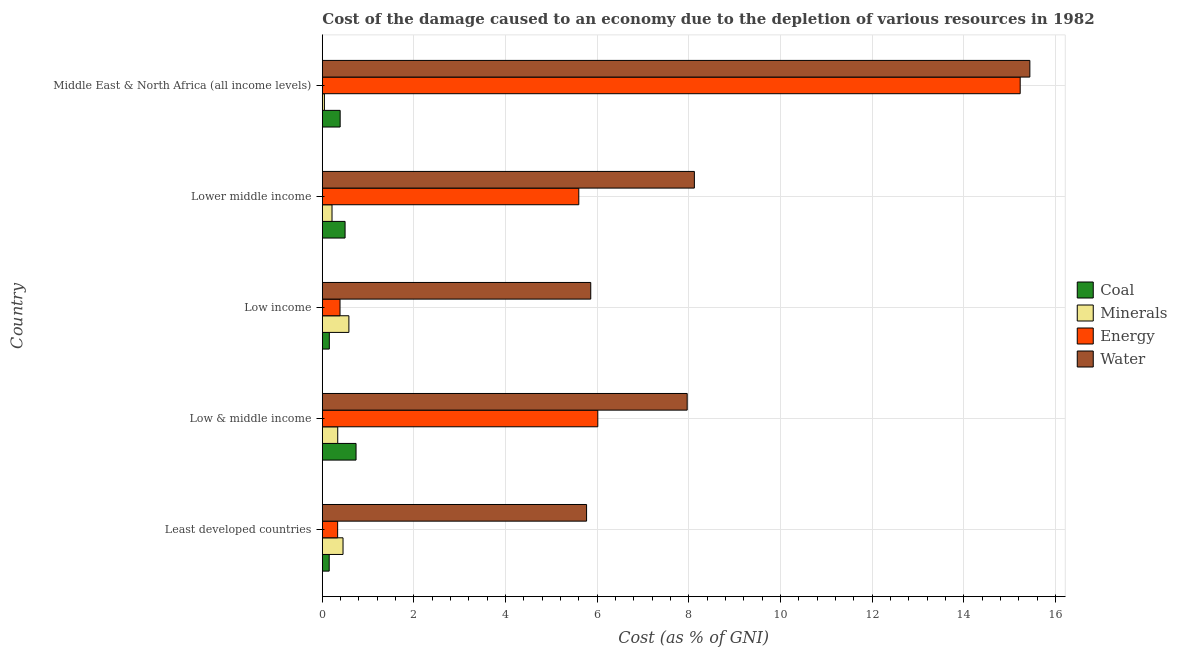How many bars are there on the 4th tick from the top?
Ensure brevity in your answer.  4. What is the cost of damage due to depletion of coal in Least developed countries?
Your answer should be compact. 0.15. Across all countries, what is the maximum cost of damage due to depletion of coal?
Provide a short and direct response. 0.74. Across all countries, what is the minimum cost of damage due to depletion of minerals?
Keep it short and to the point. 0.05. In which country was the cost of damage due to depletion of minerals maximum?
Provide a succinct answer. Low income. In which country was the cost of damage due to depletion of coal minimum?
Offer a terse response. Least developed countries. What is the total cost of damage due to depletion of energy in the graph?
Provide a short and direct response. 27.56. What is the difference between the cost of damage due to depletion of coal in Least developed countries and that in Lower middle income?
Provide a short and direct response. -0.35. What is the difference between the cost of damage due to depletion of energy in Least developed countries and the cost of damage due to depletion of water in Lower middle income?
Your response must be concise. -7.78. What is the average cost of damage due to depletion of coal per country?
Your answer should be very brief. 0.39. What is the difference between the cost of damage due to depletion of minerals and cost of damage due to depletion of energy in Middle East & North Africa (all income levels)?
Your response must be concise. -15.18. In how many countries, is the cost of damage due to depletion of coal greater than 6.8 %?
Give a very brief answer. 0. What is the ratio of the cost of damage due to depletion of minerals in Lower middle income to that in Middle East & North Africa (all income levels)?
Ensure brevity in your answer.  4.67. Is the difference between the cost of damage due to depletion of water in Least developed countries and Low & middle income greater than the difference between the cost of damage due to depletion of minerals in Least developed countries and Low & middle income?
Your response must be concise. No. What is the difference between the highest and the second highest cost of damage due to depletion of energy?
Offer a very short reply. 9.22. What is the difference between the highest and the lowest cost of damage due to depletion of minerals?
Keep it short and to the point. 0.53. In how many countries, is the cost of damage due to depletion of energy greater than the average cost of damage due to depletion of energy taken over all countries?
Provide a succinct answer. 3. Is it the case that in every country, the sum of the cost of damage due to depletion of minerals and cost of damage due to depletion of water is greater than the sum of cost of damage due to depletion of coal and cost of damage due to depletion of energy?
Make the answer very short. Yes. What does the 4th bar from the top in Lower middle income represents?
Offer a terse response. Coal. What does the 4th bar from the bottom in Least developed countries represents?
Offer a terse response. Water. Is it the case that in every country, the sum of the cost of damage due to depletion of coal and cost of damage due to depletion of minerals is greater than the cost of damage due to depletion of energy?
Offer a very short reply. No. How many bars are there?
Provide a succinct answer. 20. Are all the bars in the graph horizontal?
Offer a very short reply. Yes. How many countries are there in the graph?
Provide a succinct answer. 5. How many legend labels are there?
Offer a very short reply. 4. What is the title of the graph?
Your answer should be very brief. Cost of the damage caused to an economy due to the depletion of various resources in 1982 . What is the label or title of the X-axis?
Your answer should be compact. Cost (as % of GNI). What is the Cost (as % of GNI) in Coal in Least developed countries?
Your answer should be compact. 0.15. What is the Cost (as % of GNI) in Minerals in Least developed countries?
Your answer should be compact. 0.45. What is the Cost (as % of GNI) in Energy in Least developed countries?
Provide a short and direct response. 0.33. What is the Cost (as % of GNI) in Water in Least developed countries?
Keep it short and to the point. 5.77. What is the Cost (as % of GNI) of Coal in Low & middle income?
Your response must be concise. 0.74. What is the Cost (as % of GNI) in Minerals in Low & middle income?
Ensure brevity in your answer.  0.34. What is the Cost (as % of GNI) in Energy in Low & middle income?
Provide a succinct answer. 6.01. What is the Cost (as % of GNI) of Water in Low & middle income?
Your answer should be compact. 7.96. What is the Cost (as % of GNI) in Coal in Low income?
Offer a terse response. 0.15. What is the Cost (as % of GNI) of Minerals in Low income?
Offer a very short reply. 0.58. What is the Cost (as % of GNI) of Energy in Low income?
Give a very brief answer. 0.39. What is the Cost (as % of GNI) of Water in Low income?
Your answer should be compact. 5.86. What is the Cost (as % of GNI) of Coal in Lower middle income?
Provide a succinct answer. 0.5. What is the Cost (as % of GNI) in Minerals in Lower middle income?
Your answer should be compact. 0.21. What is the Cost (as % of GNI) in Energy in Lower middle income?
Make the answer very short. 5.6. What is the Cost (as % of GNI) in Water in Lower middle income?
Your answer should be very brief. 8.12. What is the Cost (as % of GNI) of Coal in Middle East & North Africa (all income levels)?
Give a very brief answer. 0.39. What is the Cost (as % of GNI) of Minerals in Middle East & North Africa (all income levels)?
Your answer should be very brief. 0.05. What is the Cost (as % of GNI) in Energy in Middle East & North Africa (all income levels)?
Provide a succinct answer. 15.23. What is the Cost (as % of GNI) of Water in Middle East & North Africa (all income levels)?
Give a very brief answer. 15.44. Across all countries, what is the maximum Cost (as % of GNI) in Coal?
Keep it short and to the point. 0.74. Across all countries, what is the maximum Cost (as % of GNI) of Minerals?
Give a very brief answer. 0.58. Across all countries, what is the maximum Cost (as % of GNI) in Energy?
Your answer should be very brief. 15.23. Across all countries, what is the maximum Cost (as % of GNI) of Water?
Offer a terse response. 15.44. Across all countries, what is the minimum Cost (as % of GNI) in Coal?
Keep it short and to the point. 0.15. Across all countries, what is the minimum Cost (as % of GNI) in Minerals?
Your answer should be compact. 0.05. Across all countries, what is the minimum Cost (as % of GNI) of Energy?
Offer a very short reply. 0.33. Across all countries, what is the minimum Cost (as % of GNI) in Water?
Provide a short and direct response. 5.77. What is the total Cost (as % of GNI) in Coal in the graph?
Make the answer very short. 1.92. What is the total Cost (as % of GNI) in Minerals in the graph?
Provide a short and direct response. 1.62. What is the total Cost (as % of GNI) of Energy in the graph?
Give a very brief answer. 27.56. What is the total Cost (as % of GNI) in Water in the graph?
Make the answer very short. 43.15. What is the difference between the Cost (as % of GNI) in Coal in Least developed countries and that in Low & middle income?
Your answer should be very brief. -0.59. What is the difference between the Cost (as % of GNI) in Minerals in Least developed countries and that in Low & middle income?
Keep it short and to the point. 0.12. What is the difference between the Cost (as % of GNI) of Energy in Least developed countries and that in Low & middle income?
Make the answer very short. -5.68. What is the difference between the Cost (as % of GNI) of Water in Least developed countries and that in Low & middle income?
Provide a succinct answer. -2.2. What is the difference between the Cost (as % of GNI) of Coal in Least developed countries and that in Low income?
Give a very brief answer. -0. What is the difference between the Cost (as % of GNI) of Minerals in Least developed countries and that in Low income?
Your answer should be compact. -0.13. What is the difference between the Cost (as % of GNI) in Energy in Least developed countries and that in Low income?
Ensure brevity in your answer.  -0.05. What is the difference between the Cost (as % of GNI) of Water in Least developed countries and that in Low income?
Make the answer very short. -0.09. What is the difference between the Cost (as % of GNI) of Coal in Least developed countries and that in Lower middle income?
Provide a short and direct response. -0.35. What is the difference between the Cost (as % of GNI) in Minerals in Least developed countries and that in Lower middle income?
Make the answer very short. 0.24. What is the difference between the Cost (as % of GNI) of Energy in Least developed countries and that in Lower middle income?
Your answer should be very brief. -5.26. What is the difference between the Cost (as % of GNI) in Water in Least developed countries and that in Lower middle income?
Keep it short and to the point. -2.35. What is the difference between the Cost (as % of GNI) of Coal in Least developed countries and that in Middle East & North Africa (all income levels)?
Ensure brevity in your answer.  -0.24. What is the difference between the Cost (as % of GNI) in Minerals in Least developed countries and that in Middle East & North Africa (all income levels)?
Give a very brief answer. 0.41. What is the difference between the Cost (as % of GNI) of Energy in Least developed countries and that in Middle East & North Africa (all income levels)?
Ensure brevity in your answer.  -14.9. What is the difference between the Cost (as % of GNI) in Water in Least developed countries and that in Middle East & North Africa (all income levels)?
Ensure brevity in your answer.  -9.67. What is the difference between the Cost (as % of GNI) in Coal in Low & middle income and that in Low income?
Offer a very short reply. 0.58. What is the difference between the Cost (as % of GNI) of Minerals in Low & middle income and that in Low income?
Keep it short and to the point. -0.24. What is the difference between the Cost (as % of GNI) in Energy in Low & middle income and that in Low income?
Your answer should be very brief. 5.63. What is the difference between the Cost (as % of GNI) in Water in Low & middle income and that in Low income?
Your answer should be compact. 2.1. What is the difference between the Cost (as % of GNI) of Coal in Low & middle income and that in Lower middle income?
Your answer should be compact. 0.24. What is the difference between the Cost (as % of GNI) of Minerals in Low & middle income and that in Lower middle income?
Ensure brevity in your answer.  0.12. What is the difference between the Cost (as % of GNI) of Energy in Low & middle income and that in Lower middle income?
Your answer should be very brief. 0.41. What is the difference between the Cost (as % of GNI) of Water in Low & middle income and that in Lower middle income?
Provide a short and direct response. -0.16. What is the difference between the Cost (as % of GNI) in Coal in Low & middle income and that in Middle East & North Africa (all income levels)?
Give a very brief answer. 0.35. What is the difference between the Cost (as % of GNI) of Minerals in Low & middle income and that in Middle East & North Africa (all income levels)?
Offer a very short reply. 0.29. What is the difference between the Cost (as % of GNI) of Energy in Low & middle income and that in Middle East & North Africa (all income levels)?
Your response must be concise. -9.22. What is the difference between the Cost (as % of GNI) in Water in Low & middle income and that in Middle East & North Africa (all income levels)?
Make the answer very short. -7.48. What is the difference between the Cost (as % of GNI) of Coal in Low income and that in Lower middle income?
Give a very brief answer. -0.34. What is the difference between the Cost (as % of GNI) in Minerals in Low income and that in Lower middle income?
Offer a terse response. 0.37. What is the difference between the Cost (as % of GNI) in Energy in Low income and that in Lower middle income?
Your answer should be compact. -5.21. What is the difference between the Cost (as % of GNI) in Water in Low income and that in Lower middle income?
Give a very brief answer. -2.26. What is the difference between the Cost (as % of GNI) of Coal in Low income and that in Middle East & North Africa (all income levels)?
Keep it short and to the point. -0.24. What is the difference between the Cost (as % of GNI) in Minerals in Low income and that in Middle East & North Africa (all income levels)?
Offer a very short reply. 0.53. What is the difference between the Cost (as % of GNI) in Energy in Low income and that in Middle East & North Africa (all income levels)?
Provide a short and direct response. -14.84. What is the difference between the Cost (as % of GNI) in Water in Low income and that in Middle East & North Africa (all income levels)?
Your answer should be very brief. -9.58. What is the difference between the Cost (as % of GNI) of Coal in Lower middle income and that in Middle East & North Africa (all income levels)?
Keep it short and to the point. 0.11. What is the difference between the Cost (as % of GNI) of Minerals in Lower middle income and that in Middle East & North Africa (all income levels)?
Your answer should be compact. 0.17. What is the difference between the Cost (as % of GNI) in Energy in Lower middle income and that in Middle East & North Africa (all income levels)?
Your response must be concise. -9.63. What is the difference between the Cost (as % of GNI) in Water in Lower middle income and that in Middle East & North Africa (all income levels)?
Provide a succinct answer. -7.32. What is the difference between the Cost (as % of GNI) in Coal in Least developed countries and the Cost (as % of GNI) in Minerals in Low & middle income?
Offer a very short reply. -0.19. What is the difference between the Cost (as % of GNI) of Coal in Least developed countries and the Cost (as % of GNI) of Energy in Low & middle income?
Your response must be concise. -5.86. What is the difference between the Cost (as % of GNI) in Coal in Least developed countries and the Cost (as % of GNI) in Water in Low & middle income?
Your response must be concise. -7.81. What is the difference between the Cost (as % of GNI) in Minerals in Least developed countries and the Cost (as % of GNI) in Energy in Low & middle income?
Offer a very short reply. -5.56. What is the difference between the Cost (as % of GNI) of Minerals in Least developed countries and the Cost (as % of GNI) of Water in Low & middle income?
Make the answer very short. -7.51. What is the difference between the Cost (as % of GNI) of Energy in Least developed countries and the Cost (as % of GNI) of Water in Low & middle income?
Your answer should be compact. -7.63. What is the difference between the Cost (as % of GNI) in Coal in Least developed countries and the Cost (as % of GNI) in Minerals in Low income?
Provide a succinct answer. -0.43. What is the difference between the Cost (as % of GNI) in Coal in Least developed countries and the Cost (as % of GNI) in Energy in Low income?
Offer a terse response. -0.24. What is the difference between the Cost (as % of GNI) of Coal in Least developed countries and the Cost (as % of GNI) of Water in Low income?
Make the answer very short. -5.71. What is the difference between the Cost (as % of GNI) of Minerals in Least developed countries and the Cost (as % of GNI) of Energy in Low income?
Ensure brevity in your answer.  0.07. What is the difference between the Cost (as % of GNI) in Minerals in Least developed countries and the Cost (as % of GNI) in Water in Low income?
Provide a short and direct response. -5.41. What is the difference between the Cost (as % of GNI) in Energy in Least developed countries and the Cost (as % of GNI) in Water in Low income?
Keep it short and to the point. -5.52. What is the difference between the Cost (as % of GNI) of Coal in Least developed countries and the Cost (as % of GNI) of Minerals in Lower middle income?
Offer a very short reply. -0.06. What is the difference between the Cost (as % of GNI) in Coal in Least developed countries and the Cost (as % of GNI) in Energy in Lower middle income?
Make the answer very short. -5.45. What is the difference between the Cost (as % of GNI) of Coal in Least developed countries and the Cost (as % of GNI) of Water in Lower middle income?
Provide a short and direct response. -7.97. What is the difference between the Cost (as % of GNI) in Minerals in Least developed countries and the Cost (as % of GNI) in Energy in Lower middle income?
Provide a short and direct response. -5.14. What is the difference between the Cost (as % of GNI) in Minerals in Least developed countries and the Cost (as % of GNI) in Water in Lower middle income?
Provide a succinct answer. -7.67. What is the difference between the Cost (as % of GNI) of Energy in Least developed countries and the Cost (as % of GNI) of Water in Lower middle income?
Offer a very short reply. -7.78. What is the difference between the Cost (as % of GNI) in Coal in Least developed countries and the Cost (as % of GNI) in Minerals in Middle East & North Africa (all income levels)?
Make the answer very short. 0.1. What is the difference between the Cost (as % of GNI) in Coal in Least developed countries and the Cost (as % of GNI) in Energy in Middle East & North Africa (all income levels)?
Provide a succinct answer. -15.08. What is the difference between the Cost (as % of GNI) of Coal in Least developed countries and the Cost (as % of GNI) of Water in Middle East & North Africa (all income levels)?
Give a very brief answer. -15.29. What is the difference between the Cost (as % of GNI) in Minerals in Least developed countries and the Cost (as % of GNI) in Energy in Middle East & North Africa (all income levels)?
Offer a very short reply. -14.78. What is the difference between the Cost (as % of GNI) of Minerals in Least developed countries and the Cost (as % of GNI) of Water in Middle East & North Africa (all income levels)?
Offer a very short reply. -14.99. What is the difference between the Cost (as % of GNI) in Energy in Least developed countries and the Cost (as % of GNI) in Water in Middle East & North Africa (all income levels)?
Make the answer very short. -15.11. What is the difference between the Cost (as % of GNI) of Coal in Low & middle income and the Cost (as % of GNI) of Minerals in Low income?
Provide a short and direct response. 0.16. What is the difference between the Cost (as % of GNI) of Coal in Low & middle income and the Cost (as % of GNI) of Energy in Low income?
Keep it short and to the point. 0.35. What is the difference between the Cost (as % of GNI) of Coal in Low & middle income and the Cost (as % of GNI) of Water in Low income?
Your answer should be compact. -5.12. What is the difference between the Cost (as % of GNI) in Minerals in Low & middle income and the Cost (as % of GNI) in Water in Low income?
Make the answer very short. -5.52. What is the difference between the Cost (as % of GNI) in Energy in Low & middle income and the Cost (as % of GNI) in Water in Low income?
Give a very brief answer. 0.15. What is the difference between the Cost (as % of GNI) of Coal in Low & middle income and the Cost (as % of GNI) of Minerals in Lower middle income?
Your response must be concise. 0.52. What is the difference between the Cost (as % of GNI) of Coal in Low & middle income and the Cost (as % of GNI) of Energy in Lower middle income?
Your answer should be very brief. -4.86. What is the difference between the Cost (as % of GNI) of Coal in Low & middle income and the Cost (as % of GNI) of Water in Lower middle income?
Make the answer very short. -7.38. What is the difference between the Cost (as % of GNI) of Minerals in Low & middle income and the Cost (as % of GNI) of Energy in Lower middle income?
Offer a terse response. -5.26. What is the difference between the Cost (as % of GNI) of Minerals in Low & middle income and the Cost (as % of GNI) of Water in Lower middle income?
Provide a succinct answer. -7.78. What is the difference between the Cost (as % of GNI) of Energy in Low & middle income and the Cost (as % of GNI) of Water in Lower middle income?
Offer a terse response. -2.11. What is the difference between the Cost (as % of GNI) in Coal in Low & middle income and the Cost (as % of GNI) in Minerals in Middle East & North Africa (all income levels)?
Offer a terse response. 0.69. What is the difference between the Cost (as % of GNI) of Coal in Low & middle income and the Cost (as % of GNI) of Energy in Middle East & North Africa (all income levels)?
Offer a very short reply. -14.49. What is the difference between the Cost (as % of GNI) of Coal in Low & middle income and the Cost (as % of GNI) of Water in Middle East & North Africa (all income levels)?
Offer a very short reply. -14.7. What is the difference between the Cost (as % of GNI) of Minerals in Low & middle income and the Cost (as % of GNI) of Energy in Middle East & North Africa (all income levels)?
Provide a short and direct response. -14.89. What is the difference between the Cost (as % of GNI) of Minerals in Low & middle income and the Cost (as % of GNI) of Water in Middle East & North Africa (all income levels)?
Keep it short and to the point. -15.1. What is the difference between the Cost (as % of GNI) of Energy in Low & middle income and the Cost (as % of GNI) of Water in Middle East & North Africa (all income levels)?
Your response must be concise. -9.43. What is the difference between the Cost (as % of GNI) of Coal in Low income and the Cost (as % of GNI) of Minerals in Lower middle income?
Your response must be concise. -0.06. What is the difference between the Cost (as % of GNI) in Coal in Low income and the Cost (as % of GNI) in Energy in Lower middle income?
Offer a terse response. -5.44. What is the difference between the Cost (as % of GNI) of Coal in Low income and the Cost (as % of GNI) of Water in Lower middle income?
Ensure brevity in your answer.  -7.97. What is the difference between the Cost (as % of GNI) in Minerals in Low income and the Cost (as % of GNI) in Energy in Lower middle income?
Offer a very short reply. -5.02. What is the difference between the Cost (as % of GNI) in Minerals in Low income and the Cost (as % of GNI) in Water in Lower middle income?
Keep it short and to the point. -7.54. What is the difference between the Cost (as % of GNI) in Energy in Low income and the Cost (as % of GNI) in Water in Lower middle income?
Provide a short and direct response. -7.73. What is the difference between the Cost (as % of GNI) in Coal in Low income and the Cost (as % of GNI) in Minerals in Middle East & North Africa (all income levels)?
Give a very brief answer. 0.11. What is the difference between the Cost (as % of GNI) of Coal in Low income and the Cost (as % of GNI) of Energy in Middle East & North Africa (all income levels)?
Your answer should be very brief. -15.08. What is the difference between the Cost (as % of GNI) in Coal in Low income and the Cost (as % of GNI) in Water in Middle East & North Africa (all income levels)?
Your answer should be very brief. -15.29. What is the difference between the Cost (as % of GNI) in Minerals in Low income and the Cost (as % of GNI) in Energy in Middle East & North Africa (all income levels)?
Ensure brevity in your answer.  -14.65. What is the difference between the Cost (as % of GNI) in Minerals in Low income and the Cost (as % of GNI) in Water in Middle East & North Africa (all income levels)?
Keep it short and to the point. -14.86. What is the difference between the Cost (as % of GNI) of Energy in Low income and the Cost (as % of GNI) of Water in Middle East & North Africa (all income levels)?
Your response must be concise. -15.05. What is the difference between the Cost (as % of GNI) in Coal in Lower middle income and the Cost (as % of GNI) in Minerals in Middle East & North Africa (all income levels)?
Offer a very short reply. 0.45. What is the difference between the Cost (as % of GNI) of Coal in Lower middle income and the Cost (as % of GNI) of Energy in Middle East & North Africa (all income levels)?
Provide a short and direct response. -14.73. What is the difference between the Cost (as % of GNI) in Coal in Lower middle income and the Cost (as % of GNI) in Water in Middle East & North Africa (all income levels)?
Make the answer very short. -14.94. What is the difference between the Cost (as % of GNI) of Minerals in Lower middle income and the Cost (as % of GNI) of Energy in Middle East & North Africa (all income levels)?
Your response must be concise. -15.02. What is the difference between the Cost (as % of GNI) in Minerals in Lower middle income and the Cost (as % of GNI) in Water in Middle East & North Africa (all income levels)?
Provide a short and direct response. -15.23. What is the difference between the Cost (as % of GNI) of Energy in Lower middle income and the Cost (as % of GNI) of Water in Middle East & North Africa (all income levels)?
Offer a terse response. -9.84. What is the average Cost (as % of GNI) in Coal per country?
Make the answer very short. 0.38. What is the average Cost (as % of GNI) in Minerals per country?
Your answer should be compact. 0.32. What is the average Cost (as % of GNI) of Energy per country?
Your response must be concise. 5.51. What is the average Cost (as % of GNI) in Water per country?
Offer a very short reply. 8.63. What is the difference between the Cost (as % of GNI) of Coal and Cost (as % of GNI) of Minerals in Least developed countries?
Keep it short and to the point. -0.3. What is the difference between the Cost (as % of GNI) of Coal and Cost (as % of GNI) of Energy in Least developed countries?
Offer a very short reply. -0.18. What is the difference between the Cost (as % of GNI) of Coal and Cost (as % of GNI) of Water in Least developed countries?
Offer a terse response. -5.62. What is the difference between the Cost (as % of GNI) in Minerals and Cost (as % of GNI) in Energy in Least developed countries?
Offer a terse response. 0.12. What is the difference between the Cost (as % of GNI) of Minerals and Cost (as % of GNI) of Water in Least developed countries?
Provide a succinct answer. -5.31. What is the difference between the Cost (as % of GNI) in Energy and Cost (as % of GNI) in Water in Least developed countries?
Provide a succinct answer. -5.43. What is the difference between the Cost (as % of GNI) in Coal and Cost (as % of GNI) in Minerals in Low & middle income?
Your answer should be compact. 0.4. What is the difference between the Cost (as % of GNI) in Coal and Cost (as % of GNI) in Energy in Low & middle income?
Ensure brevity in your answer.  -5.28. What is the difference between the Cost (as % of GNI) in Coal and Cost (as % of GNI) in Water in Low & middle income?
Give a very brief answer. -7.23. What is the difference between the Cost (as % of GNI) in Minerals and Cost (as % of GNI) in Energy in Low & middle income?
Your answer should be very brief. -5.68. What is the difference between the Cost (as % of GNI) of Minerals and Cost (as % of GNI) of Water in Low & middle income?
Give a very brief answer. -7.63. What is the difference between the Cost (as % of GNI) of Energy and Cost (as % of GNI) of Water in Low & middle income?
Keep it short and to the point. -1.95. What is the difference between the Cost (as % of GNI) in Coal and Cost (as % of GNI) in Minerals in Low income?
Ensure brevity in your answer.  -0.43. What is the difference between the Cost (as % of GNI) in Coal and Cost (as % of GNI) in Energy in Low income?
Your answer should be compact. -0.23. What is the difference between the Cost (as % of GNI) in Coal and Cost (as % of GNI) in Water in Low income?
Keep it short and to the point. -5.71. What is the difference between the Cost (as % of GNI) of Minerals and Cost (as % of GNI) of Energy in Low income?
Your answer should be very brief. 0.19. What is the difference between the Cost (as % of GNI) of Minerals and Cost (as % of GNI) of Water in Low income?
Ensure brevity in your answer.  -5.28. What is the difference between the Cost (as % of GNI) in Energy and Cost (as % of GNI) in Water in Low income?
Ensure brevity in your answer.  -5.47. What is the difference between the Cost (as % of GNI) of Coal and Cost (as % of GNI) of Minerals in Lower middle income?
Your answer should be compact. 0.29. What is the difference between the Cost (as % of GNI) of Coal and Cost (as % of GNI) of Energy in Lower middle income?
Give a very brief answer. -5.1. What is the difference between the Cost (as % of GNI) in Coal and Cost (as % of GNI) in Water in Lower middle income?
Your answer should be compact. -7.62. What is the difference between the Cost (as % of GNI) in Minerals and Cost (as % of GNI) in Energy in Lower middle income?
Make the answer very short. -5.39. What is the difference between the Cost (as % of GNI) of Minerals and Cost (as % of GNI) of Water in Lower middle income?
Your answer should be very brief. -7.91. What is the difference between the Cost (as % of GNI) of Energy and Cost (as % of GNI) of Water in Lower middle income?
Offer a terse response. -2.52. What is the difference between the Cost (as % of GNI) in Coal and Cost (as % of GNI) in Minerals in Middle East & North Africa (all income levels)?
Your answer should be compact. 0.34. What is the difference between the Cost (as % of GNI) of Coal and Cost (as % of GNI) of Energy in Middle East & North Africa (all income levels)?
Ensure brevity in your answer.  -14.84. What is the difference between the Cost (as % of GNI) of Coal and Cost (as % of GNI) of Water in Middle East & North Africa (all income levels)?
Your answer should be compact. -15.05. What is the difference between the Cost (as % of GNI) of Minerals and Cost (as % of GNI) of Energy in Middle East & North Africa (all income levels)?
Offer a very short reply. -15.18. What is the difference between the Cost (as % of GNI) in Minerals and Cost (as % of GNI) in Water in Middle East & North Africa (all income levels)?
Offer a terse response. -15.39. What is the difference between the Cost (as % of GNI) of Energy and Cost (as % of GNI) of Water in Middle East & North Africa (all income levels)?
Offer a very short reply. -0.21. What is the ratio of the Cost (as % of GNI) in Coal in Least developed countries to that in Low & middle income?
Ensure brevity in your answer.  0.2. What is the ratio of the Cost (as % of GNI) in Minerals in Least developed countries to that in Low & middle income?
Offer a terse response. 1.34. What is the ratio of the Cost (as % of GNI) in Energy in Least developed countries to that in Low & middle income?
Ensure brevity in your answer.  0.06. What is the ratio of the Cost (as % of GNI) in Water in Least developed countries to that in Low & middle income?
Keep it short and to the point. 0.72. What is the ratio of the Cost (as % of GNI) in Minerals in Least developed countries to that in Low income?
Your response must be concise. 0.78. What is the ratio of the Cost (as % of GNI) of Energy in Least developed countries to that in Low income?
Your answer should be compact. 0.87. What is the ratio of the Cost (as % of GNI) of Water in Least developed countries to that in Low income?
Offer a very short reply. 0.98. What is the ratio of the Cost (as % of GNI) in Coal in Least developed countries to that in Lower middle income?
Ensure brevity in your answer.  0.3. What is the ratio of the Cost (as % of GNI) in Minerals in Least developed countries to that in Lower middle income?
Keep it short and to the point. 2.14. What is the ratio of the Cost (as % of GNI) of Energy in Least developed countries to that in Lower middle income?
Your answer should be very brief. 0.06. What is the ratio of the Cost (as % of GNI) of Water in Least developed countries to that in Lower middle income?
Your response must be concise. 0.71. What is the ratio of the Cost (as % of GNI) in Coal in Least developed countries to that in Middle East & North Africa (all income levels)?
Offer a very short reply. 0.39. What is the ratio of the Cost (as % of GNI) in Minerals in Least developed countries to that in Middle East & North Africa (all income levels)?
Ensure brevity in your answer.  9.98. What is the ratio of the Cost (as % of GNI) in Energy in Least developed countries to that in Middle East & North Africa (all income levels)?
Give a very brief answer. 0.02. What is the ratio of the Cost (as % of GNI) of Water in Least developed countries to that in Middle East & North Africa (all income levels)?
Ensure brevity in your answer.  0.37. What is the ratio of the Cost (as % of GNI) in Coal in Low & middle income to that in Low income?
Your answer should be compact. 4.82. What is the ratio of the Cost (as % of GNI) of Minerals in Low & middle income to that in Low income?
Your response must be concise. 0.58. What is the ratio of the Cost (as % of GNI) in Energy in Low & middle income to that in Low income?
Offer a very short reply. 15.57. What is the ratio of the Cost (as % of GNI) in Water in Low & middle income to that in Low income?
Provide a short and direct response. 1.36. What is the ratio of the Cost (as % of GNI) in Coal in Low & middle income to that in Lower middle income?
Ensure brevity in your answer.  1.48. What is the ratio of the Cost (as % of GNI) in Minerals in Low & middle income to that in Lower middle income?
Make the answer very short. 1.59. What is the ratio of the Cost (as % of GNI) of Energy in Low & middle income to that in Lower middle income?
Offer a very short reply. 1.07. What is the ratio of the Cost (as % of GNI) of Water in Low & middle income to that in Lower middle income?
Offer a very short reply. 0.98. What is the ratio of the Cost (as % of GNI) of Coal in Low & middle income to that in Middle East & North Africa (all income levels)?
Ensure brevity in your answer.  1.89. What is the ratio of the Cost (as % of GNI) in Minerals in Low & middle income to that in Middle East & North Africa (all income levels)?
Your answer should be very brief. 7.42. What is the ratio of the Cost (as % of GNI) of Energy in Low & middle income to that in Middle East & North Africa (all income levels)?
Provide a succinct answer. 0.39. What is the ratio of the Cost (as % of GNI) in Water in Low & middle income to that in Middle East & North Africa (all income levels)?
Make the answer very short. 0.52. What is the ratio of the Cost (as % of GNI) in Coal in Low income to that in Lower middle income?
Your answer should be compact. 0.31. What is the ratio of the Cost (as % of GNI) in Minerals in Low income to that in Lower middle income?
Ensure brevity in your answer.  2.74. What is the ratio of the Cost (as % of GNI) in Energy in Low income to that in Lower middle income?
Keep it short and to the point. 0.07. What is the ratio of the Cost (as % of GNI) in Water in Low income to that in Lower middle income?
Your answer should be compact. 0.72. What is the ratio of the Cost (as % of GNI) of Coal in Low income to that in Middle East & North Africa (all income levels)?
Make the answer very short. 0.39. What is the ratio of the Cost (as % of GNI) in Minerals in Low income to that in Middle East & North Africa (all income levels)?
Offer a terse response. 12.8. What is the ratio of the Cost (as % of GNI) in Energy in Low income to that in Middle East & North Africa (all income levels)?
Give a very brief answer. 0.03. What is the ratio of the Cost (as % of GNI) in Water in Low income to that in Middle East & North Africa (all income levels)?
Your answer should be very brief. 0.38. What is the ratio of the Cost (as % of GNI) in Coal in Lower middle income to that in Middle East & North Africa (all income levels)?
Offer a terse response. 1.28. What is the ratio of the Cost (as % of GNI) of Minerals in Lower middle income to that in Middle East & North Africa (all income levels)?
Keep it short and to the point. 4.67. What is the ratio of the Cost (as % of GNI) of Energy in Lower middle income to that in Middle East & North Africa (all income levels)?
Keep it short and to the point. 0.37. What is the ratio of the Cost (as % of GNI) in Water in Lower middle income to that in Middle East & North Africa (all income levels)?
Provide a succinct answer. 0.53. What is the difference between the highest and the second highest Cost (as % of GNI) of Coal?
Your answer should be compact. 0.24. What is the difference between the highest and the second highest Cost (as % of GNI) of Minerals?
Keep it short and to the point. 0.13. What is the difference between the highest and the second highest Cost (as % of GNI) of Energy?
Your response must be concise. 9.22. What is the difference between the highest and the second highest Cost (as % of GNI) in Water?
Provide a succinct answer. 7.32. What is the difference between the highest and the lowest Cost (as % of GNI) in Coal?
Your answer should be compact. 0.59. What is the difference between the highest and the lowest Cost (as % of GNI) in Minerals?
Offer a terse response. 0.53. What is the difference between the highest and the lowest Cost (as % of GNI) in Energy?
Your response must be concise. 14.9. What is the difference between the highest and the lowest Cost (as % of GNI) of Water?
Offer a very short reply. 9.67. 